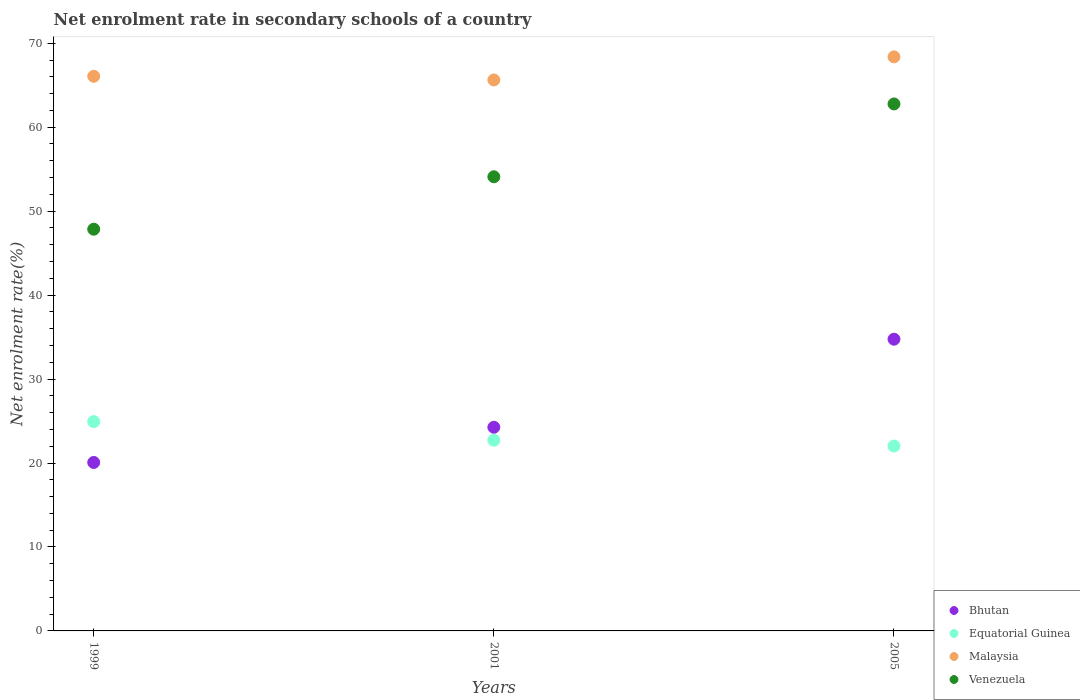How many different coloured dotlines are there?
Give a very brief answer. 4. Is the number of dotlines equal to the number of legend labels?
Keep it short and to the point. Yes. What is the net enrolment rate in secondary schools in Equatorial Guinea in 2001?
Provide a short and direct response. 22.71. Across all years, what is the maximum net enrolment rate in secondary schools in Venezuela?
Offer a terse response. 62.77. Across all years, what is the minimum net enrolment rate in secondary schools in Bhutan?
Give a very brief answer. 20.07. What is the total net enrolment rate in secondary schools in Bhutan in the graph?
Make the answer very short. 79.07. What is the difference between the net enrolment rate in secondary schools in Venezuela in 1999 and that in 2005?
Provide a succinct answer. -14.92. What is the difference between the net enrolment rate in secondary schools in Bhutan in 2005 and the net enrolment rate in secondary schools in Venezuela in 2001?
Give a very brief answer. -19.35. What is the average net enrolment rate in secondary schools in Equatorial Guinea per year?
Provide a short and direct response. 23.22. In the year 2001, what is the difference between the net enrolment rate in secondary schools in Equatorial Guinea and net enrolment rate in secondary schools in Malaysia?
Offer a very short reply. -42.91. What is the ratio of the net enrolment rate in secondary schools in Venezuela in 1999 to that in 2001?
Provide a succinct answer. 0.88. Is the net enrolment rate in secondary schools in Equatorial Guinea in 1999 less than that in 2005?
Offer a terse response. No. What is the difference between the highest and the second highest net enrolment rate in secondary schools in Equatorial Guinea?
Your answer should be compact. 2.22. What is the difference between the highest and the lowest net enrolment rate in secondary schools in Equatorial Guinea?
Ensure brevity in your answer.  2.91. Is it the case that in every year, the sum of the net enrolment rate in secondary schools in Venezuela and net enrolment rate in secondary schools in Bhutan  is greater than the net enrolment rate in secondary schools in Malaysia?
Offer a very short reply. Yes. Does the net enrolment rate in secondary schools in Bhutan monotonically increase over the years?
Offer a very short reply. Yes. Is the net enrolment rate in secondary schools in Bhutan strictly greater than the net enrolment rate in secondary schools in Malaysia over the years?
Make the answer very short. No. How many years are there in the graph?
Offer a terse response. 3. Are the values on the major ticks of Y-axis written in scientific E-notation?
Keep it short and to the point. No. Does the graph contain grids?
Make the answer very short. No. How many legend labels are there?
Offer a very short reply. 4. What is the title of the graph?
Keep it short and to the point. Net enrolment rate in secondary schools of a country. What is the label or title of the Y-axis?
Your response must be concise. Net enrolment rate(%). What is the Net enrolment rate(%) of Bhutan in 1999?
Offer a very short reply. 20.07. What is the Net enrolment rate(%) in Equatorial Guinea in 1999?
Provide a short and direct response. 24.93. What is the Net enrolment rate(%) in Malaysia in 1999?
Ensure brevity in your answer.  66.06. What is the Net enrolment rate(%) in Venezuela in 1999?
Your answer should be very brief. 47.85. What is the Net enrolment rate(%) in Bhutan in 2001?
Keep it short and to the point. 24.26. What is the Net enrolment rate(%) of Equatorial Guinea in 2001?
Give a very brief answer. 22.71. What is the Net enrolment rate(%) of Malaysia in 2001?
Provide a succinct answer. 65.63. What is the Net enrolment rate(%) in Venezuela in 2001?
Ensure brevity in your answer.  54.09. What is the Net enrolment rate(%) of Bhutan in 2005?
Offer a terse response. 34.75. What is the Net enrolment rate(%) of Equatorial Guinea in 2005?
Provide a short and direct response. 22.02. What is the Net enrolment rate(%) in Malaysia in 2005?
Offer a very short reply. 68.38. What is the Net enrolment rate(%) of Venezuela in 2005?
Your response must be concise. 62.77. Across all years, what is the maximum Net enrolment rate(%) in Bhutan?
Offer a very short reply. 34.75. Across all years, what is the maximum Net enrolment rate(%) of Equatorial Guinea?
Offer a very short reply. 24.93. Across all years, what is the maximum Net enrolment rate(%) in Malaysia?
Provide a succinct answer. 68.38. Across all years, what is the maximum Net enrolment rate(%) in Venezuela?
Keep it short and to the point. 62.77. Across all years, what is the minimum Net enrolment rate(%) in Bhutan?
Your answer should be compact. 20.07. Across all years, what is the minimum Net enrolment rate(%) of Equatorial Guinea?
Offer a terse response. 22.02. Across all years, what is the minimum Net enrolment rate(%) of Malaysia?
Your response must be concise. 65.63. Across all years, what is the minimum Net enrolment rate(%) in Venezuela?
Give a very brief answer. 47.85. What is the total Net enrolment rate(%) in Bhutan in the graph?
Your answer should be very brief. 79.07. What is the total Net enrolment rate(%) in Equatorial Guinea in the graph?
Make the answer very short. 69.66. What is the total Net enrolment rate(%) in Malaysia in the graph?
Provide a succinct answer. 200.06. What is the total Net enrolment rate(%) in Venezuela in the graph?
Make the answer very short. 164.71. What is the difference between the Net enrolment rate(%) of Bhutan in 1999 and that in 2001?
Your answer should be compact. -4.19. What is the difference between the Net enrolment rate(%) in Equatorial Guinea in 1999 and that in 2001?
Give a very brief answer. 2.22. What is the difference between the Net enrolment rate(%) of Malaysia in 1999 and that in 2001?
Keep it short and to the point. 0.43. What is the difference between the Net enrolment rate(%) in Venezuela in 1999 and that in 2001?
Your response must be concise. -6.25. What is the difference between the Net enrolment rate(%) in Bhutan in 1999 and that in 2005?
Keep it short and to the point. -14.68. What is the difference between the Net enrolment rate(%) of Equatorial Guinea in 1999 and that in 2005?
Your response must be concise. 2.91. What is the difference between the Net enrolment rate(%) in Malaysia in 1999 and that in 2005?
Provide a succinct answer. -2.31. What is the difference between the Net enrolment rate(%) in Venezuela in 1999 and that in 2005?
Give a very brief answer. -14.92. What is the difference between the Net enrolment rate(%) in Bhutan in 2001 and that in 2005?
Your response must be concise. -10.49. What is the difference between the Net enrolment rate(%) in Equatorial Guinea in 2001 and that in 2005?
Give a very brief answer. 0.69. What is the difference between the Net enrolment rate(%) of Malaysia in 2001 and that in 2005?
Make the answer very short. -2.75. What is the difference between the Net enrolment rate(%) in Venezuela in 2001 and that in 2005?
Your answer should be compact. -8.67. What is the difference between the Net enrolment rate(%) in Bhutan in 1999 and the Net enrolment rate(%) in Equatorial Guinea in 2001?
Offer a terse response. -2.65. What is the difference between the Net enrolment rate(%) in Bhutan in 1999 and the Net enrolment rate(%) in Malaysia in 2001?
Your answer should be very brief. -45.56. What is the difference between the Net enrolment rate(%) in Bhutan in 1999 and the Net enrolment rate(%) in Venezuela in 2001?
Keep it short and to the point. -34.03. What is the difference between the Net enrolment rate(%) of Equatorial Guinea in 1999 and the Net enrolment rate(%) of Malaysia in 2001?
Make the answer very short. -40.7. What is the difference between the Net enrolment rate(%) in Equatorial Guinea in 1999 and the Net enrolment rate(%) in Venezuela in 2001?
Give a very brief answer. -29.16. What is the difference between the Net enrolment rate(%) in Malaysia in 1999 and the Net enrolment rate(%) in Venezuela in 2001?
Offer a terse response. 11.97. What is the difference between the Net enrolment rate(%) in Bhutan in 1999 and the Net enrolment rate(%) in Equatorial Guinea in 2005?
Give a very brief answer. -1.95. What is the difference between the Net enrolment rate(%) of Bhutan in 1999 and the Net enrolment rate(%) of Malaysia in 2005?
Your answer should be compact. -48.31. What is the difference between the Net enrolment rate(%) of Bhutan in 1999 and the Net enrolment rate(%) of Venezuela in 2005?
Offer a terse response. -42.7. What is the difference between the Net enrolment rate(%) of Equatorial Guinea in 1999 and the Net enrolment rate(%) of Malaysia in 2005?
Your answer should be very brief. -43.45. What is the difference between the Net enrolment rate(%) in Equatorial Guinea in 1999 and the Net enrolment rate(%) in Venezuela in 2005?
Your response must be concise. -37.84. What is the difference between the Net enrolment rate(%) in Malaysia in 1999 and the Net enrolment rate(%) in Venezuela in 2005?
Your answer should be compact. 3.29. What is the difference between the Net enrolment rate(%) in Bhutan in 2001 and the Net enrolment rate(%) in Equatorial Guinea in 2005?
Your answer should be compact. 2.24. What is the difference between the Net enrolment rate(%) of Bhutan in 2001 and the Net enrolment rate(%) of Malaysia in 2005?
Provide a short and direct response. -44.12. What is the difference between the Net enrolment rate(%) in Bhutan in 2001 and the Net enrolment rate(%) in Venezuela in 2005?
Ensure brevity in your answer.  -38.51. What is the difference between the Net enrolment rate(%) of Equatorial Guinea in 2001 and the Net enrolment rate(%) of Malaysia in 2005?
Ensure brevity in your answer.  -45.66. What is the difference between the Net enrolment rate(%) of Equatorial Guinea in 2001 and the Net enrolment rate(%) of Venezuela in 2005?
Your answer should be compact. -40.05. What is the difference between the Net enrolment rate(%) in Malaysia in 2001 and the Net enrolment rate(%) in Venezuela in 2005?
Make the answer very short. 2.86. What is the average Net enrolment rate(%) in Bhutan per year?
Provide a succinct answer. 26.36. What is the average Net enrolment rate(%) in Equatorial Guinea per year?
Give a very brief answer. 23.22. What is the average Net enrolment rate(%) of Malaysia per year?
Your response must be concise. 66.69. What is the average Net enrolment rate(%) of Venezuela per year?
Keep it short and to the point. 54.9. In the year 1999, what is the difference between the Net enrolment rate(%) in Bhutan and Net enrolment rate(%) in Equatorial Guinea?
Keep it short and to the point. -4.86. In the year 1999, what is the difference between the Net enrolment rate(%) of Bhutan and Net enrolment rate(%) of Malaysia?
Provide a succinct answer. -46. In the year 1999, what is the difference between the Net enrolment rate(%) in Bhutan and Net enrolment rate(%) in Venezuela?
Provide a short and direct response. -27.78. In the year 1999, what is the difference between the Net enrolment rate(%) in Equatorial Guinea and Net enrolment rate(%) in Malaysia?
Your answer should be very brief. -41.13. In the year 1999, what is the difference between the Net enrolment rate(%) of Equatorial Guinea and Net enrolment rate(%) of Venezuela?
Your answer should be very brief. -22.92. In the year 1999, what is the difference between the Net enrolment rate(%) of Malaysia and Net enrolment rate(%) of Venezuela?
Your response must be concise. 18.21. In the year 2001, what is the difference between the Net enrolment rate(%) of Bhutan and Net enrolment rate(%) of Equatorial Guinea?
Provide a succinct answer. 1.54. In the year 2001, what is the difference between the Net enrolment rate(%) of Bhutan and Net enrolment rate(%) of Malaysia?
Your answer should be very brief. -41.37. In the year 2001, what is the difference between the Net enrolment rate(%) in Bhutan and Net enrolment rate(%) in Venezuela?
Your answer should be very brief. -29.84. In the year 2001, what is the difference between the Net enrolment rate(%) in Equatorial Guinea and Net enrolment rate(%) in Malaysia?
Your response must be concise. -42.91. In the year 2001, what is the difference between the Net enrolment rate(%) of Equatorial Guinea and Net enrolment rate(%) of Venezuela?
Make the answer very short. -31.38. In the year 2001, what is the difference between the Net enrolment rate(%) in Malaysia and Net enrolment rate(%) in Venezuela?
Provide a short and direct response. 11.53. In the year 2005, what is the difference between the Net enrolment rate(%) of Bhutan and Net enrolment rate(%) of Equatorial Guinea?
Provide a succinct answer. 12.73. In the year 2005, what is the difference between the Net enrolment rate(%) of Bhutan and Net enrolment rate(%) of Malaysia?
Your response must be concise. -33.63. In the year 2005, what is the difference between the Net enrolment rate(%) of Bhutan and Net enrolment rate(%) of Venezuela?
Keep it short and to the point. -28.02. In the year 2005, what is the difference between the Net enrolment rate(%) in Equatorial Guinea and Net enrolment rate(%) in Malaysia?
Make the answer very short. -46.36. In the year 2005, what is the difference between the Net enrolment rate(%) in Equatorial Guinea and Net enrolment rate(%) in Venezuela?
Your answer should be compact. -40.75. In the year 2005, what is the difference between the Net enrolment rate(%) in Malaysia and Net enrolment rate(%) in Venezuela?
Provide a short and direct response. 5.61. What is the ratio of the Net enrolment rate(%) in Bhutan in 1999 to that in 2001?
Your response must be concise. 0.83. What is the ratio of the Net enrolment rate(%) in Equatorial Guinea in 1999 to that in 2001?
Provide a short and direct response. 1.1. What is the ratio of the Net enrolment rate(%) of Malaysia in 1999 to that in 2001?
Ensure brevity in your answer.  1.01. What is the ratio of the Net enrolment rate(%) in Venezuela in 1999 to that in 2001?
Ensure brevity in your answer.  0.88. What is the ratio of the Net enrolment rate(%) of Bhutan in 1999 to that in 2005?
Give a very brief answer. 0.58. What is the ratio of the Net enrolment rate(%) of Equatorial Guinea in 1999 to that in 2005?
Provide a short and direct response. 1.13. What is the ratio of the Net enrolment rate(%) of Malaysia in 1999 to that in 2005?
Provide a succinct answer. 0.97. What is the ratio of the Net enrolment rate(%) of Venezuela in 1999 to that in 2005?
Your response must be concise. 0.76. What is the ratio of the Net enrolment rate(%) in Bhutan in 2001 to that in 2005?
Give a very brief answer. 0.7. What is the ratio of the Net enrolment rate(%) of Equatorial Guinea in 2001 to that in 2005?
Your response must be concise. 1.03. What is the ratio of the Net enrolment rate(%) in Malaysia in 2001 to that in 2005?
Provide a succinct answer. 0.96. What is the ratio of the Net enrolment rate(%) in Venezuela in 2001 to that in 2005?
Make the answer very short. 0.86. What is the difference between the highest and the second highest Net enrolment rate(%) of Bhutan?
Provide a short and direct response. 10.49. What is the difference between the highest and the second highest Net enrolment rate(%) in Equatorial Guinea?
Your answer should be very brief. 2.22. What is the difference between the highest and the second highest Net enrolment rate(%) in Malaysia?
Your answer should be very brief. 2.31. What is the difference between the highest and the second highest Net enrolment rate(%) of Venezuela?
Your answer should be compact. 8.67. What is the difference between the highest and the lowest Net enrolment rate(%) in Bhutan?
Make the answer very short. 14.68. What is the difference between the highest and the lowest Net enrolment rate(%) in Equatorial Guinea?
Ensure brevity in your answer.  2.91. What is the difference between the highest and the lowest Net enrolment rate(%) in Malaysia?
Provide a short and direct response. 2.75. What is the difference between the highest and the lowest Net enrolment rate(%) in Venezuela?
Your answer should be very brief. 14.92. 